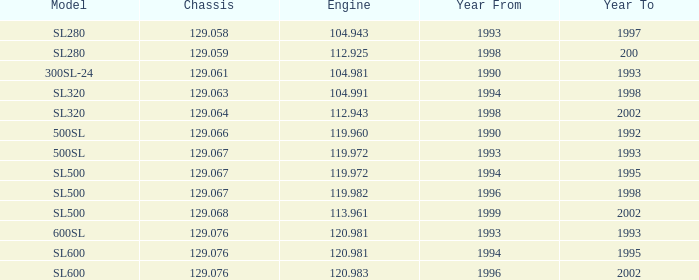Could you parse the entire table? {'header': ['Model', 'Chassis', 'Engine', 'Year From', 'Year To'], 'rows': [['SL280', '129.058', '104.943', '1993', '1997'], ['SL280', '129.059', '112.925', '1998', '200'], ['300SL-24', '129.061', '104.981', '1990', '1993'], ['SL320', '129.063', '104.991', '1994', '1998'], ['SL320', '129.064', '112.943', '1998', '2002'], ['500SL', '129.066', '119.960', '1990', '1992'], ['500SL', '129.067', '119.972', '1993', '1993'], ['SL500', '129.067', '119.972', '1994', '1995'], ['SL500', '129.067', '119.982', '1996', '1998'], ['SL500', '129.068', '113.961', '1999', '2002'], ['600SL', '129.076', '120.981', '1993', '1993'], ['SL600', '129.076', '120.981', '1994', '1995'], ['SL600', '129.076', '120.983', '1996', '2002']]} Which engine features a model of sl500 and a chassis less than 12 None. 